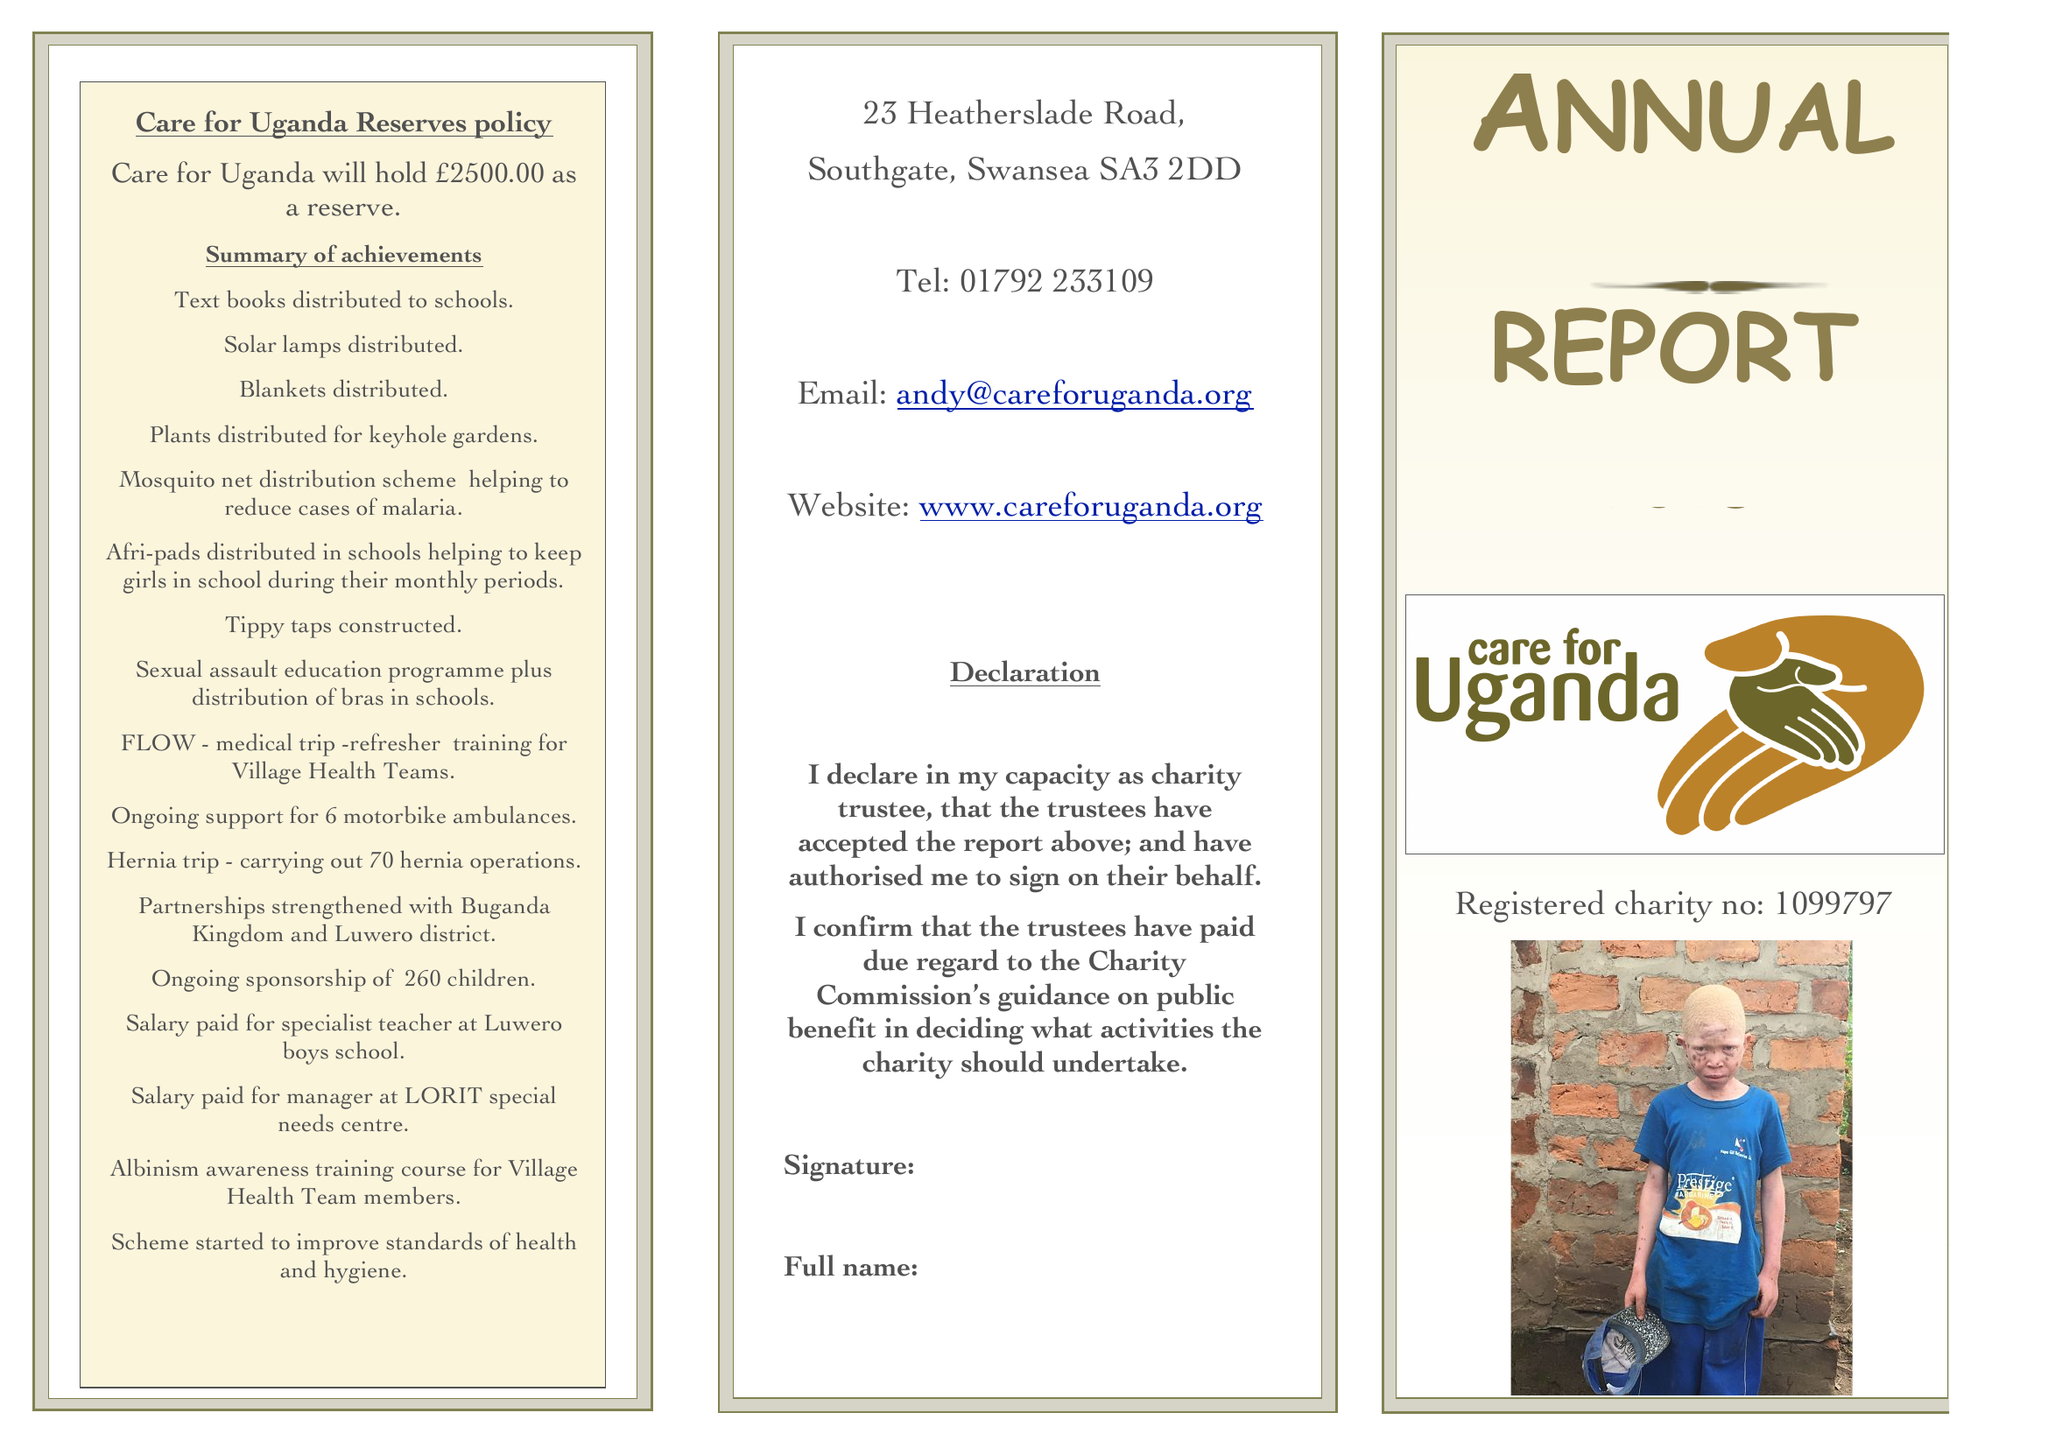What is the value for the charity_name?
Answer the question using a single word or phrase. Care For Uganda 